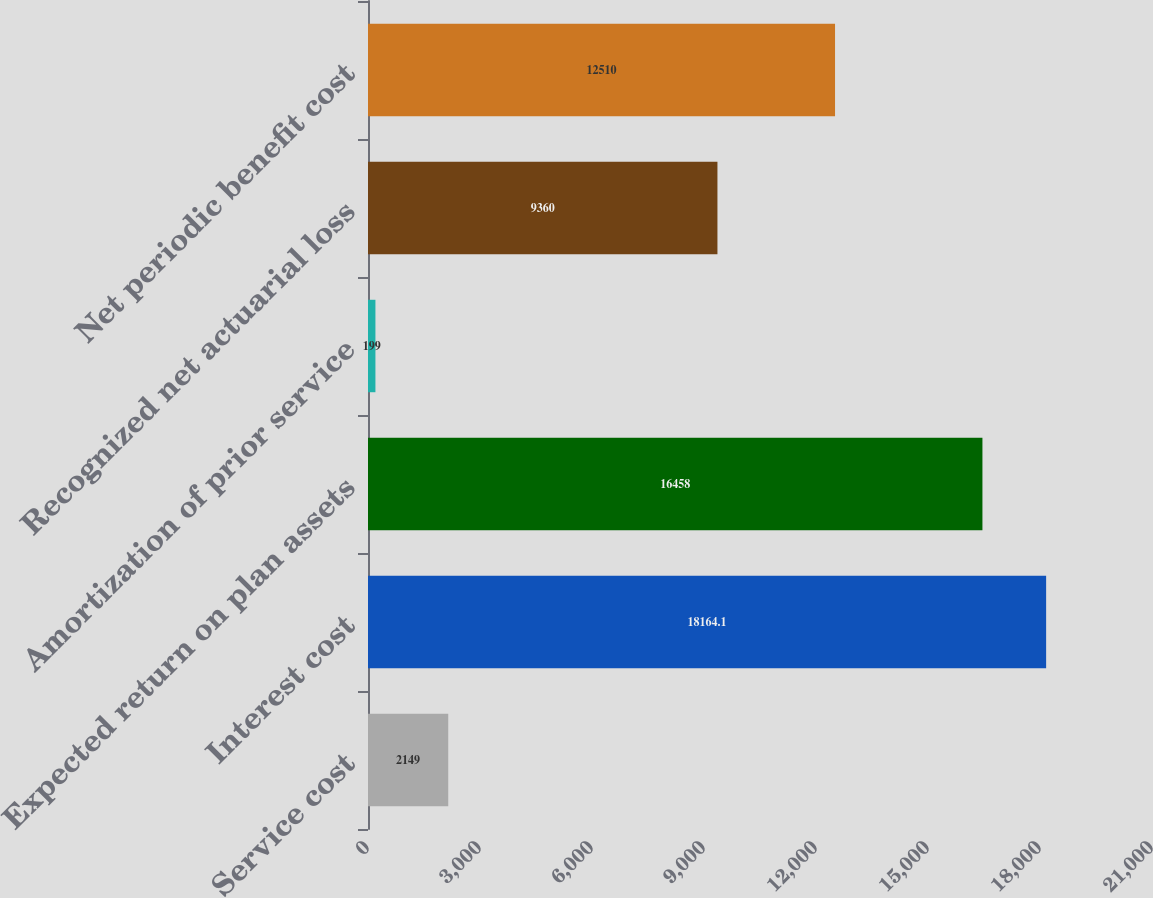<chart> <loc_0><loc_0><loc_500><loc_500><bar_chart><fcel>Service cost<fcel>Interest cost<fcel>Expected return on plan assets<fcel>Amortization of prior service<fcel>Recognized net actuarial loss<fcel>Net periodic benefit cost<nl><fcel>2149<fcel>18164.1<fcel>16458<fcel>199<fcel>9360<fcel>12510<nl></chart> 